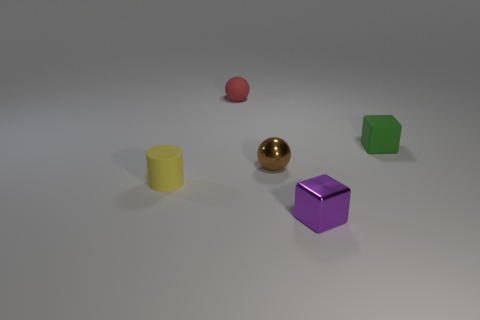Are there any tiny green things of the same shape as the small brown thing?
Your answer should be compact. No. How many objects are either small red rubber objects on the right side of the cylinder or tiny green matte cubes?
Your response must be concise. 2. Are there more small matte blocks than tiny purple cylinders?
Make the answer very short. Yes. Is there a yellow matte cylinder that has the same size as the yellow thing?
Give a very brief answer. No. How many things are cubes that are to the right of the tiny purple shiny block or small blocks in front of the metallic sphere?
Make the answer very short. 2. What is the color of the block that is in front of the block behind the purple metallic block?
Offer a terse response. Purple. There is a small cylinder that is made of the same material as the small green cube; what color is it?
Provide a succinct answer. Yellow. How many shiny objects have the same color as the small matte sphere?
Ensure brevity in your answer.  0. What number of objects are metallic cubes or tiny matte cubes?
Give a very brief answer. 2. There is a purple metal thing that is the same size as the rubber sphere; what is its shape?
Make the answer very short. Cube. 